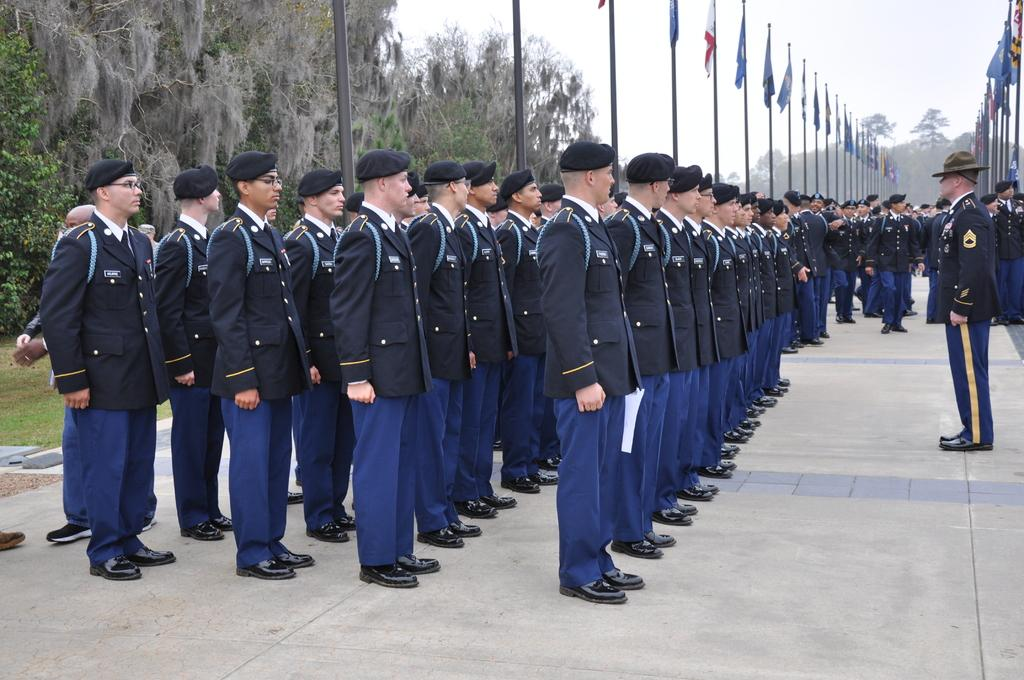How many people are in the image? There is a group of people standing in the image, but the exact number cannot be determined from the provided facts. What can be seen in the image besides the group of people? There are flags, trees, the sky, a road, and grass visible in the image. What is the color of the sky in the image? The sky is visible at the top of the image, but the color cannot be determined from the provided facts. What type of surface is the road made of? The type of surface the road is made of cannot be determined from the provided facts. What type of egg is being used to attack the trees in the image? There is no egg or attack present in the image; it features a group of people, flags, trees, the sky, a road, and grass. 